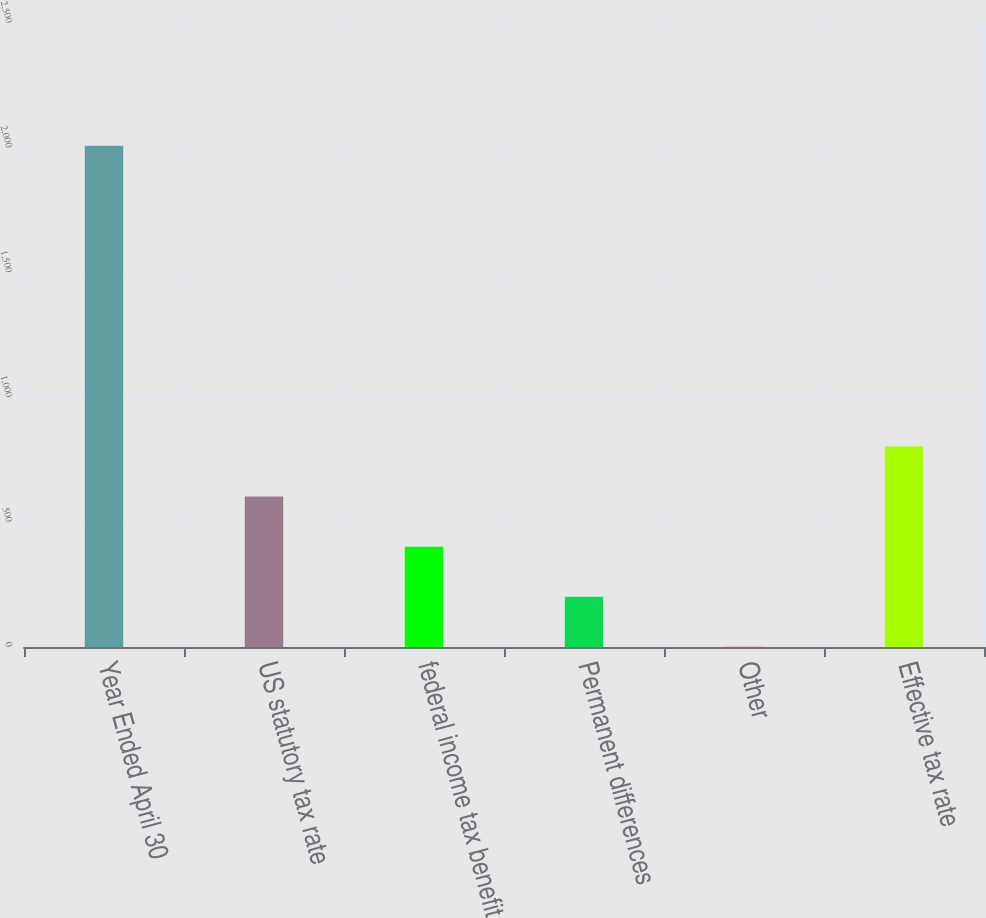<chart> <loc_0><loc_0><loc_500><loc_500><bar_chart><fcel>Year Ended April 30<fcel>US statutory tax rate<fcel>federal income tax benefit<fcel>Permanent differences<fcel>Other<fcel>Effective tax rate<nl><fcel>2008<fcel>602.82<fcel>402.08<fcel>201.34<fcel>0.6<fcel>803.56<nl></chart> 